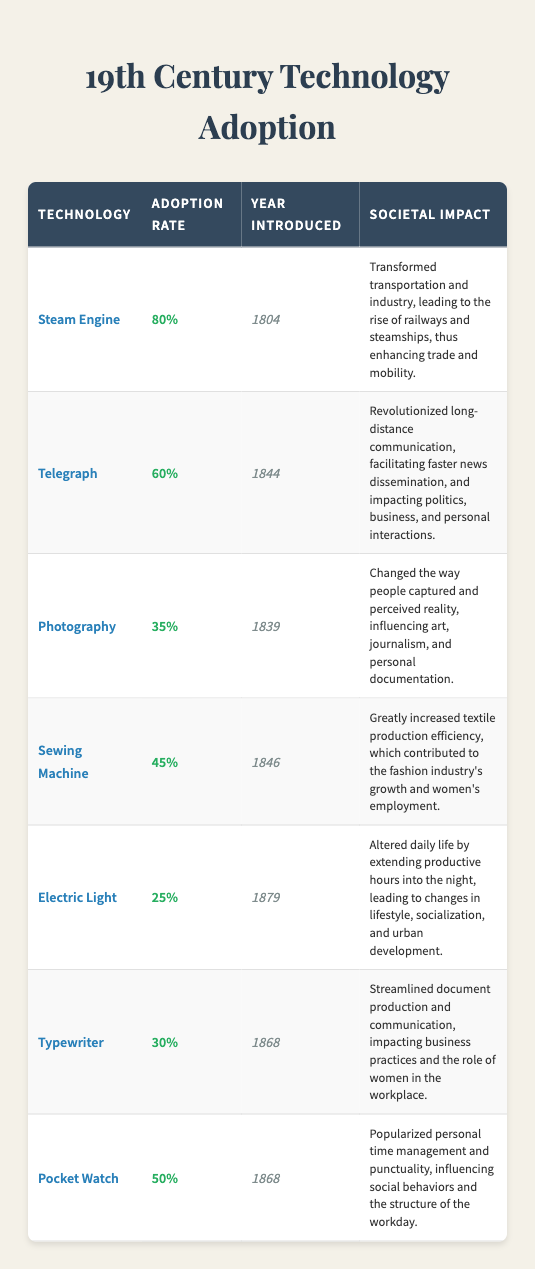What was the adoption rate of the Steam Engine? The adoption rate for the Steam Engine is directly listed in the table under the "Adoption Rate" column. It shows 80%.
Answer: 80% Which technology had the lowest adoption rate and what was it? By comparing the adoption rates listed, we find that the Electric Light has the lowest rate at 25%.
Answer: Electric Light, 25% True or False: The Telegraph was introduced after the Photography. In the table, the year introduced for the Telegraph is 1844 and for Photography, it is 1839. Since 1844 is later than 1839, the statement is false.
Answer: False What percentage difference in adoption rates exists between the Sewing Machine and the Typewriter? The adoption rate of the Sewing Machine is 45% and the Typewriter is 30%. The difference is 45% - 30% = 15%.
Answer: 15% Which two technologies had an adoption rate of over 50% and what impact did they have on society? The Steam Engine (80%) and the Telegraph (60%) both had adoption rates over 50%. The Steam Engine transformed transportation and industry, while the Telegraph revolutionized long-distance communication.
Answer: Steam Engine, Telegraph What was the average adoption rate of the technologies introduced before 1850? The technologies introduced before 1850 are the Steam Engine (80%), Photography (35%), Telegraph (60%), and Sewing Machine (45%). The average is (80 + 35 + 60 + 45) / 4 = 55%.
Answer: 55% True or False: The Pocket Watch was introduced in the same year as the Typewriter. The Pocket Watch was introduced in 1868 and the Typewriter was also introduced in 1868. Since they share the same year, the statement is true.
Answer: True Which technology has had the most significant impact on urban development? The Electric Light is noted in the table for altering daily life by extending productive hours into the night, which directly relates to changes in urban development.
Answer: Electric Light What is the ratio of the adoption rate of the Sewing Machine to that of the Pocket Watch? The Sewing Machine has an adoption rate of 45% and the Pocket Watch has a rate of 50%. The ratio is 45:50, which simplifies to 9:10.
Answer: 9:10 